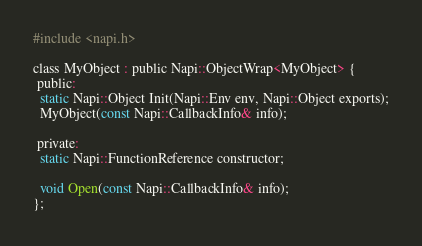Convert code to text. <code><loc_0><loc_0><loc_500><loc_500><_C_>#include <napi.h>

class MyObject : public Napi::ObjectWrap<MyObject> {
 public:
  static Napi::Object Init(Napi::Env env, Napi::Object exports);
  MyObject(const Napi::CallbackInfo& info);

 private:
  static Napi::FunctionReference constructor;

  void Open(const Napi::CallbackInfo& info);
};

</code> 